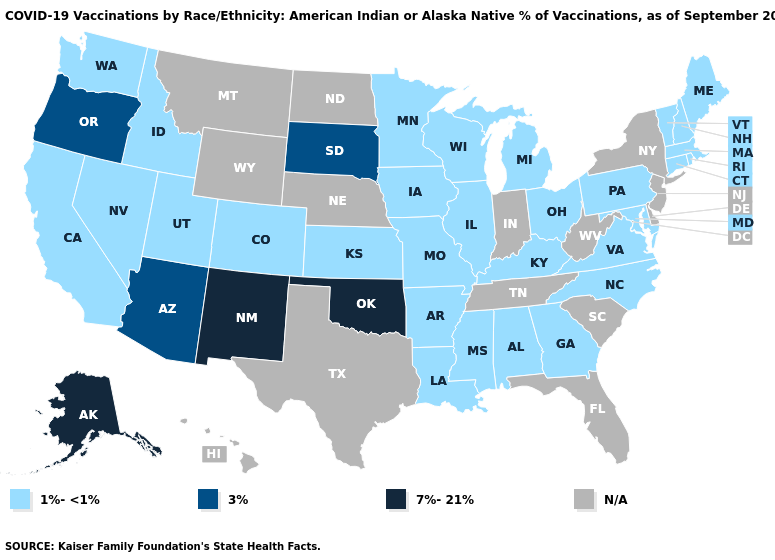Is the legend a continuous bar?
Be succinct. No. What is the value of Minnesota?
Answer briefly. 1%-<1%. What is the highest value in the MidWest ?
Short answer required. 3%. Name the states that have a value in the range 7%-21%?
Concise answer only. Alaska, New Mexico, Oklahoma. Name the states that have a value in the range 1%-<1%?
Write a very short answer. Alabama, Arkansas, California, Colorado, Connecticut, Georgia, Idaho, Illinois, Iowa, Kansas, Kentucky, Louisiana, Maine, Maryland, Massachusetts, Michigan, Minnesota, Mississippi, Missouri, Nevada, New Hampshire, North Carolina, Ohio, Pennsylvania, Rhode Island, Utah, Vermont, Virginia, Washington, Wisconsin. What is the lowest value in the USA?
Keep it brief. 1%-<1%. What is the lowest value in the USA?
Concise answer only. 1%-<1%. What is the highest value in the South ?
Be succinct. 7%-21%. What is the value of Wisconsin?
Concise answer only. 1%-<1%. Name the states that have a value in the range 1%-<1%?
Keep it brief. Alabama, Arkansas, California, Colorado, Connecticut, Georgia, Idaho, Illinois, Iowa, Kansas, Kentucky, Louisiana, Maine, Maryland, Massachusetts, Michigan, Minnesota, Mississippi, Missouri, Nevada, New Hampshire, North Carolina, Ohio, Pennsylvania, Rhode Island, Utah, Vermont, Virginia, Washington, Wisconsin. Does New Mexico have the highest value in the USA?
Keep it brief. Yes. Name the states that have a value in the range 7%-21%?
Answer briefly. Alaska, New Mexico, Oklahoma. Among the states that border Louisiana , which have the lowest value?
Be succinct. Arkansas, Mississippi. Does the map have missing data?
Quick response, please. Yes. 